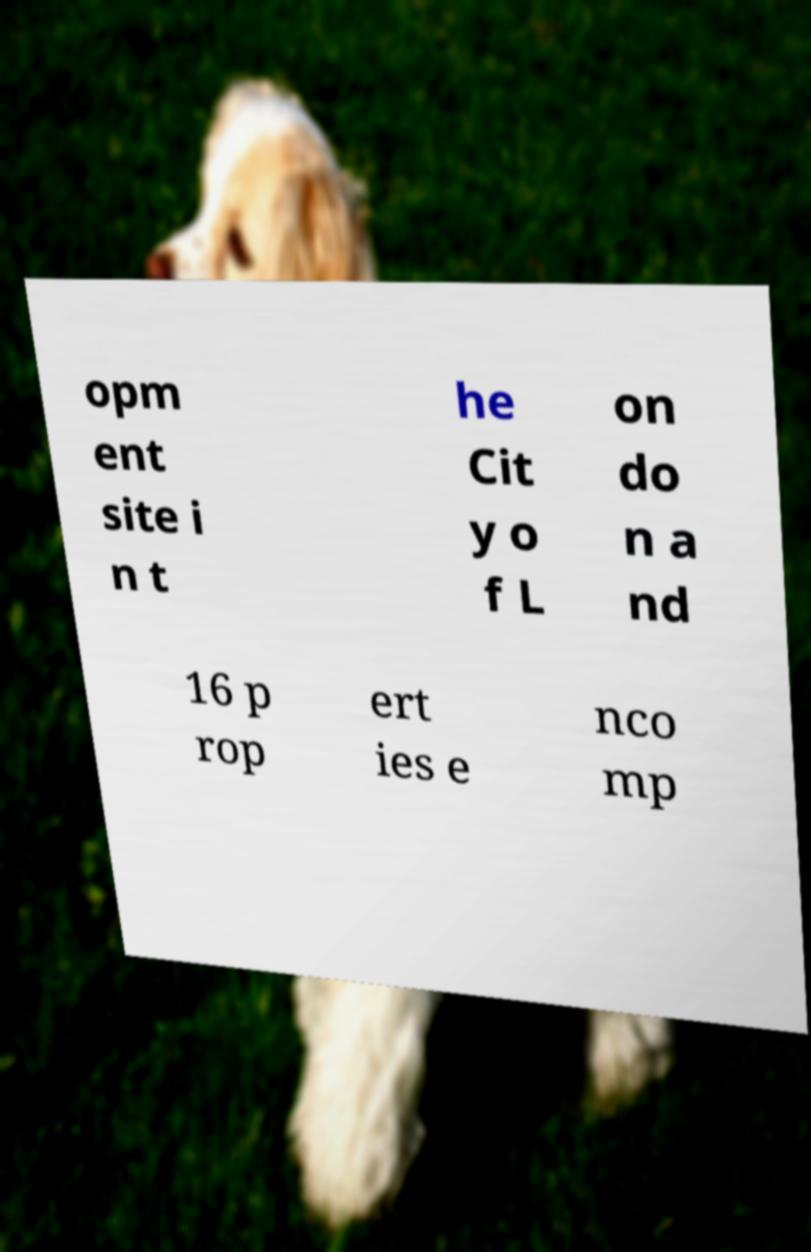There's text embedded in this image that I need extracted. Can you transcribe it verbatim? opm ent site i n t he Cit y o f L on do n a nd 16 p rop ert ies e nco mp 